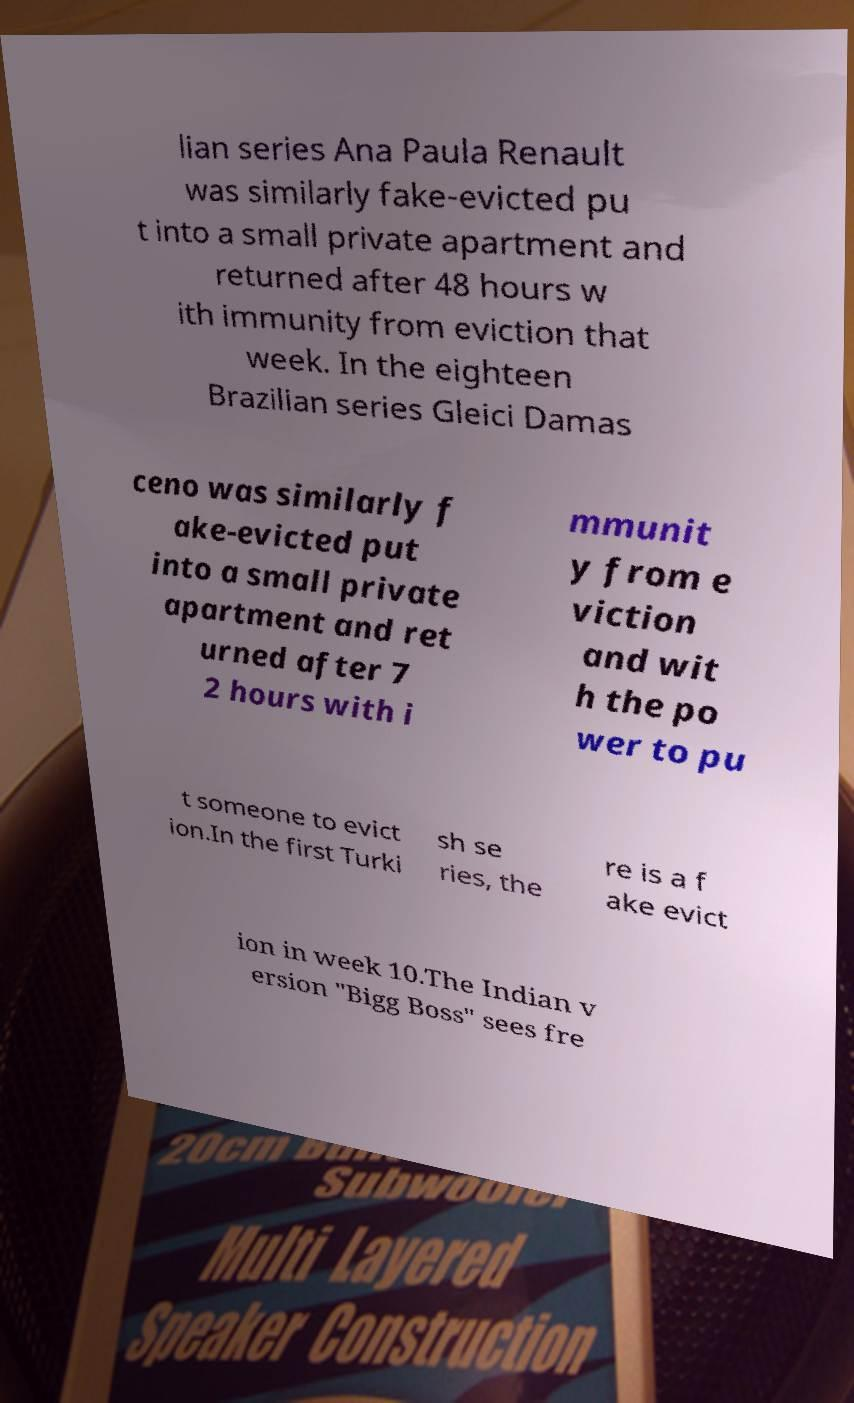Could you assist in decoding the text presented in this image and type it out clearly? lian series Ana Paula Renault was similarly fake-evicted pu t into a small private apartment and returned after 48 hours w ith immunity from eviction that week. In the eighteen Brazilian series Gleici Damas ceno was similarly f ake-evicted put into a small private apartment and ret urned after 7 2 hours with i mmunit y from e viction and wit h the po wer to pu t someone to evict ion.In the first Turki sh se ries, the re is a f ake evict ion in week 10.The Indian v ersion "Bigg Boss" sees fre 